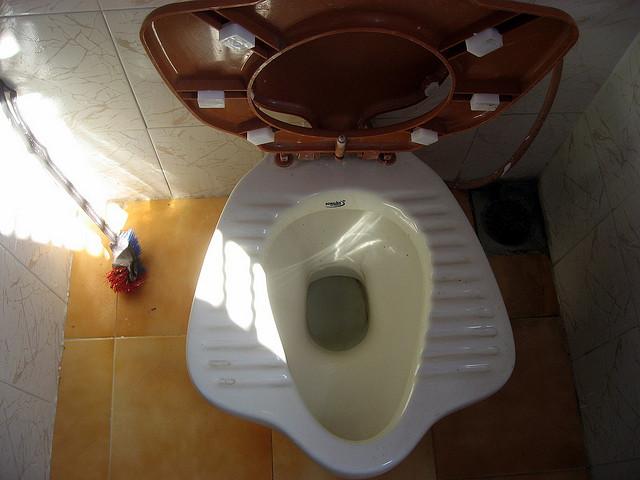What is the purpose of the ridges around the rim?
Quick response, please. Safety. Is there a toilet?
Write a very short answer. Yes. What color are the tiles?
Answer briefly. Orange. 